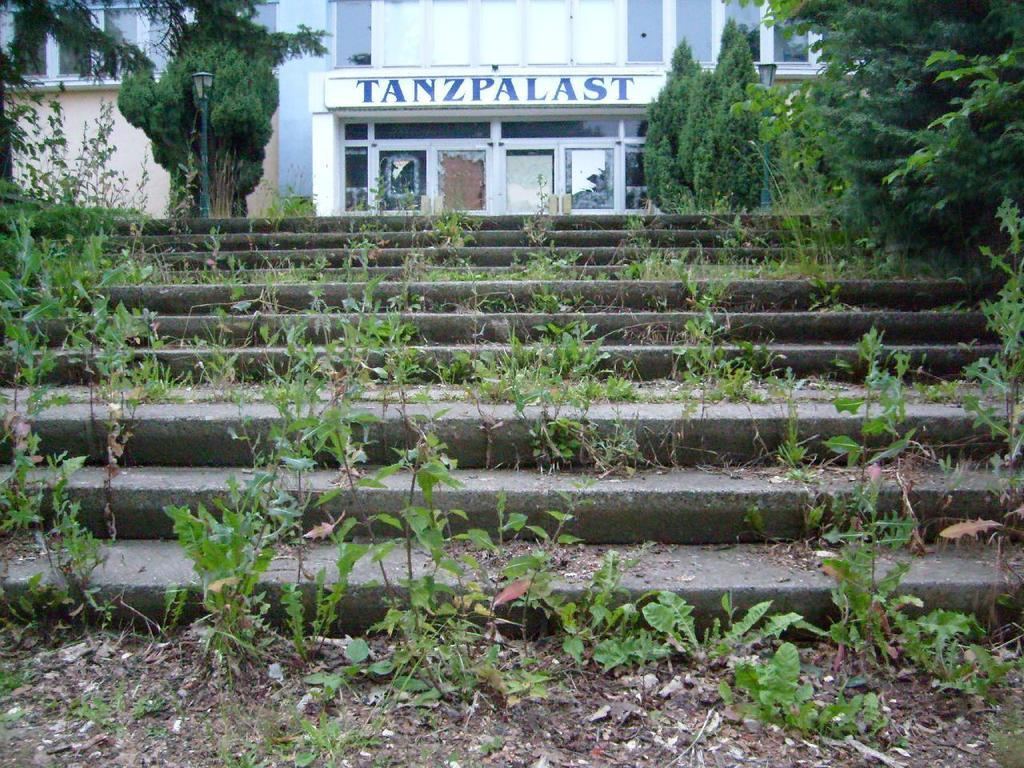What type of structure is in the image? There is a building in the image. What can be seen in front of the building? Trees are visible in front of the building. What type of vegetation is present in the image besides the trees? Small plants are present in the image. What architectural feature is visible in the image? A staircase is visible in the image. What type of street fixture is visible in the image? A street light pole is visible in the image. What type of frame is visible around the building in the image? There is no frame visible around the building in the image. 